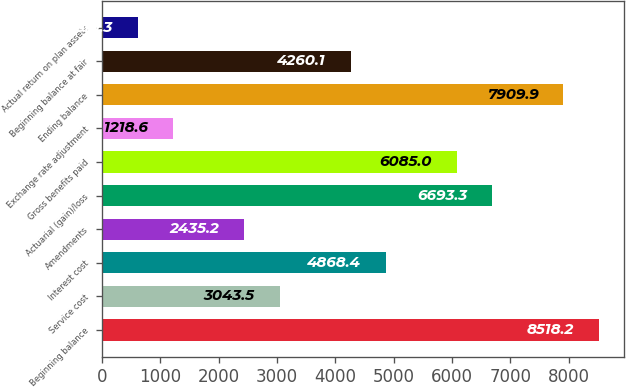Convert chart. <chart><loc_0><loc_0><loc_500><loc_500><bar_chart><fcel>Beginning balance<fcel>Service cost<fcel>Interest cost<fcel>Amendments<fcel>Actuarial (gain)/loss<fcel>Gross benefits paid<fcel>Exchange rate adjustment<fcel>Ending balance<fcel>Beginning balance at fair<fcel>Actual return on plan assets<nl><fcel>8518.2<fcel>3043.5<fcel>4868.4<fcel>2435.2<fcel>6693.3<fcel>6085<fcel>1218.6<fcel>7909.9<fcel>4260.1<fcel>610.3<nl></chart> 